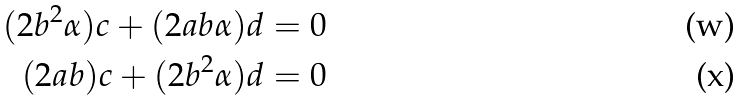<formula> <loc_0><loc_0><loc_500><loc_500>( 2 b ^ { 2 } \alpha ) c + ( 2 a b \alpha ) d & = 0 \\ ( 2 a b ) c + ( 2 b ^ { 2 } \alpha ) d & = 0</formula> 